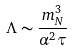<formula> <loc_0><loc_0><loc_500><loc_500>\Lambda \sim \frac { m _ { N } ^ { 3 } } { \alpha ^ { 2 } \tau }</formula> 